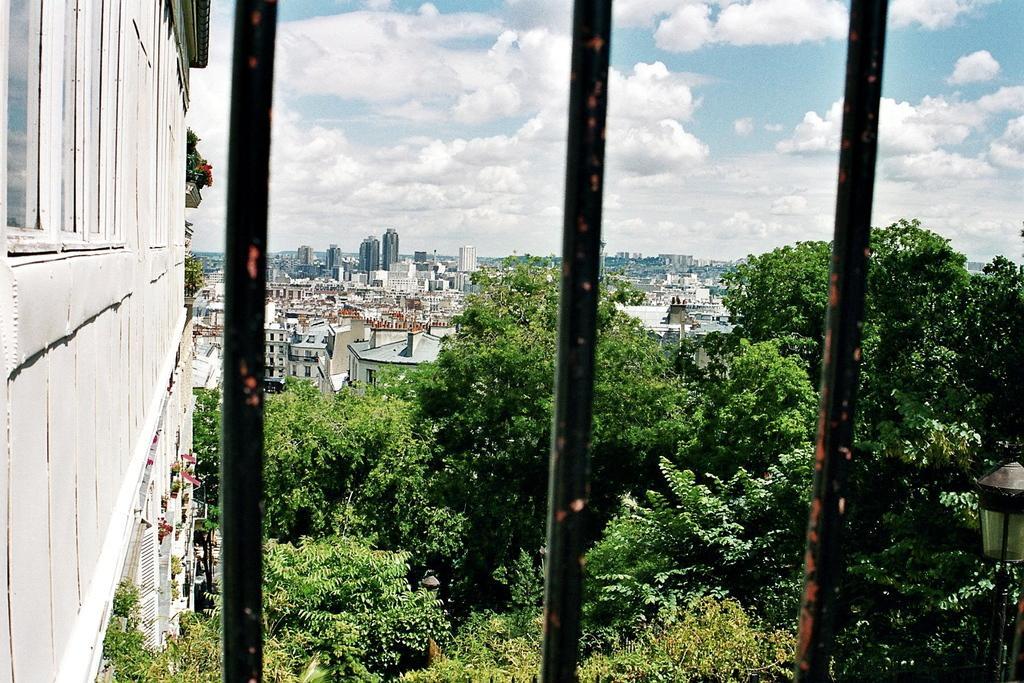Could you give a brief overview of what you see in this image? In this picture there are buildings and trees. In the foreground there are rods and there is a street light. On the left side of the image there are plants on the wall. At the top there is sky and there are clouds. 